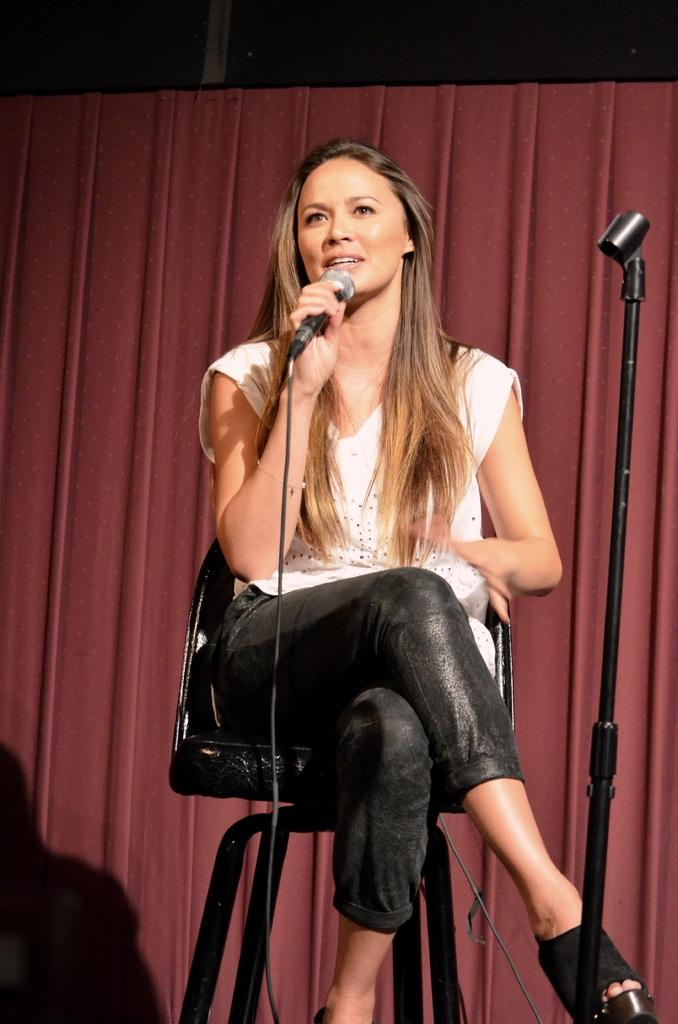Who is the main subject in the image? There is a girl in the image. What is the girl doing in the image? The girl is sitting on a chair and holding a microphone (mike). What type of books can be seen on the sugar in the image? There is no sugar or books present in the image. The girl is holding a microphone, not a book or sugar. 